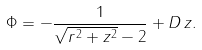<formula> <loc_0><loc_0><loc_500><loc_500>\Phi = - \frac { 1 } { \sqrt { r ^ { 2 } + z ^ { 2 } } - 2 } + D \, z .</formula> 